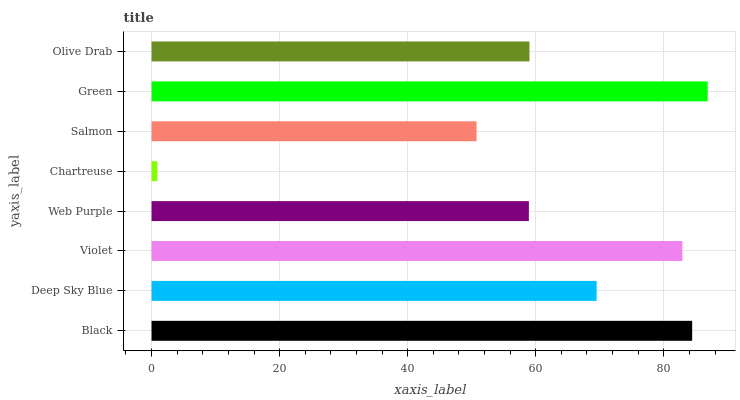Is Chartreuse the minimum?
Answer yes or no. Yes. Is Green the maximum?
Answer yes or no. Yes. Is Deep Sky Blue the minimum?
Answer yes or no. No. Is Deep Sky Blue the maximum?
Answer yes or no. No. Is Black greater than Deep Sky Blue?
Answer yes or no. Yes. Is Deep Sky Blue less than Black?
Answer yes or no. Yes. Is Deep Sky Blue greater than Black?
Answer yes or no. No. Is Black less than Deep Sky Blue?
Answer yes or no. No. Is Deep Sky Blue the high median?
Answer yes or no. Yes. Is Olive Drab the low median?
Answer yes or no. Yes. Is Violet the high median?
Answer yes or no. No. Is Web Purple the low median?
Answer yes or no. No. 